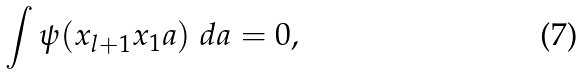Convert formula to latex. <formula><loc_0><loc_0><loc_500><loc_500>\int \psi ( x _ { l + 1 } x _ { 1 } a ) \ d a = 0 ,</formula> 